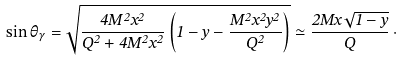Convert formula to latex. <formula><loc_0><loc_0><loc_500><loc_500>\sin \theta _ { \gamma } = \sqrt { \frac { 4 M ^ { 2 } x ^ { 2 } } { Q ^ { 2 } + 4 M ^ { 2 } x ^ { 2 } } \left ( 1 - y - \frac { M ^ { 2 } x ^ { 2 } y ^ { 2 } } { Q ^ { 2 } } \right ) } \simeq \frac { 2 M x \sqrt { 1 - y } } { Q } \, \cdot</formula> 